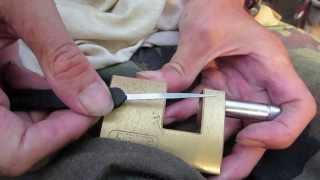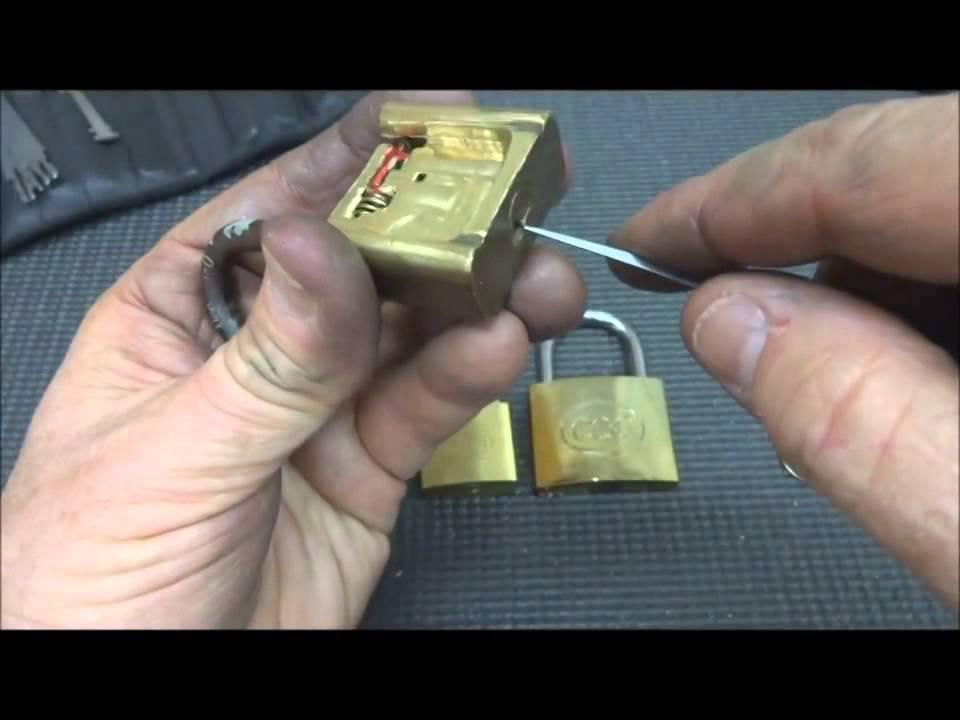The first image is the image on the left, the second image is the image on the right. Examine the images to the left and right. Is the description "The left image shows a hand holding a pointed object that is not inserted in the lock's keyhole." accurate? Answer yes or no. Yes. 